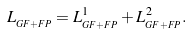<formula> <loc_0><loc_0><loc_500><loc_500>L _ { _ { G F + F P } } = L _ { _ { G F + F P } } ^ { 1 } + L _ { _ { G F + F P } } ^ { 2 } .</formula> 